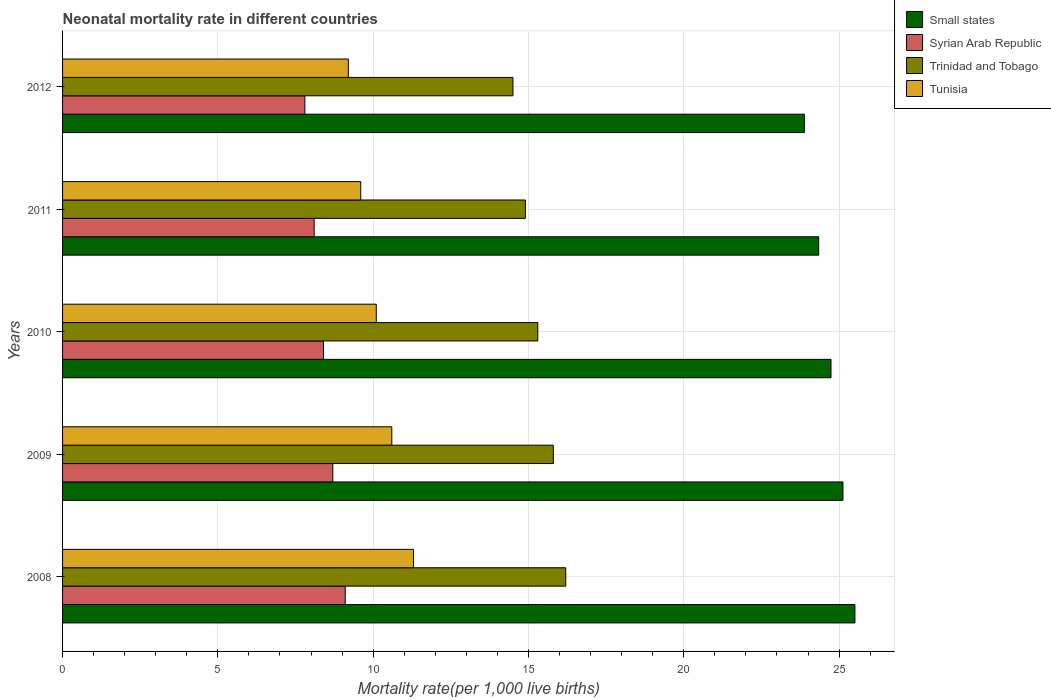How many groups of bars are there?
Ensure brevity in your answer.  5. What is the label of the 4th group of bars from the top?
Make the answer very short. 2009. What is the neonatal mortality rate in Small states in 2011?
Offer a terse response. 24.34. Across all years, what is the maximum neonatal mortality rate in Small states?
Your answer should be compact. 25.51. Across all years, what is the minimum neonatal mortality rate in Small states?
Provide a short and direct response. 23.88. In which year was the neonatal mortality rate in Tunisia minimum?
Give a very brief answer. 2012. What is the total neonatal mortality rate in Trinidad and Tobago in the graph?
Offer a terse response. 76.7. What is the difference between the neonatal mortality rate in Tunisia in 2008 and that in 2012?
Make the answer very short. 2.1. What is the difference between the neonatal mortality rate in Tunisia in 2010 and the neonatal mortality rate in Small states in 2011?
Your answer should be compact. -14.24. What is the average neonatal mortality rate in Syrian Arab Republic per year?
Offer a very short reply. 8.42. In the year 2012, what is the difference between the neonatal mortality rate in Tunisia and neonatal mortality rate in Syrian Arab Republic?
Make the answer very short. 1.4. In how many years, is the neonatal mortality rate in Tunisia greater than 12 ?
Your response must be concise. 0. What is the ratio of the neonatal mortality rate in Trinidad and Tobago in 2009 to that in 2010?
Offer a very short reply. 1.03. What is the difference between the highest and the second highest neonatal mortality rate in Small states?
Provide a succinct answer. 0.39. What is the difference between the highest and the lowest neonatal mortality rate in Tunisia?
Your answer should be compact. 2.1. What does the 3rd bar from the top in 2012 represents?
Provide a short and direct response. Syrian Arab Republic. What does the 3rd bar from the bottom in 2012 represents?
Your response must be concise. Trinidad and Tobago. Is it the case that in every year, the sum of the neonatal mortality rate in Trinidad and Tobago and neonatal mortality rate in Syrian Arab Republic is greater than the neonatal mortality rate in Small states?
Keep it short and to the point. No. How many bars are there?
Your response must be concise. 20. Are all the bars in the graph horizontal?
Offer a terse response. Yes. What is the difference between two consecutive major ticks on the X-axis?
Ensure brevity in your answer.  5. Are the values on the major ticks of X-axis written in scientific E-notation?
Your answer should be very brief. No. Where does the legend appear in the graph?
Offer a terse response. Top right. How many legend labels are there?
Your answer should be compact. 4. How are the legend labels stacked?
Make the answer very short. Vertical. What is the title of the graph?
Keep it short and to the point. Neonatal mortality rate in different countries. Does "Oman" appear as one of the legend labels in the graph?
Your answer should be compact. No. What is the label or title of the X-axis?
Provide a succinct answer. Mortality rate(per 1,0 live births). What is the Mortality rate(per 1,000 live births) of Small states in 2008?
Keep it short and to the point. 25.51. What is the Mortality rate(per 1,000 live births) of Syrian Arab Republic in 2008?
Ensure brevity in your answer.  9.1. What is the Mortality rate(per 1,000 live births) of Trinidad and Tobago in 2008?
Your answer should be compact. 16.2. What is the Mortality rate(per 1,000 live births) in Tunisia in 2008?
Offer a terse response. 11.3. What is the Mortality rate(per 1,000 live births) in Small states in 2009?
Give a very brief answer. 25.12. What is the Mortality rate(per 1,000 live births) in Syrian Arab Republic in 2009?
Keep it short and to the point. 8.7. What is the Mortality rate(per 1,000 live births) in Trinidad and Tobago in 2009?
Offer a terse response. 15.8. What is the Mortality rate(per 1,000 live births) of Tunisia in 2009?
Offer a very short reply. 10.6. What is the Mortality rate(per 1,000 live births) of Small states in 2010?
Ensure brevity in your answer.  24.74. What is the Mortality rate(per 1,000 live births) in Trinidad and Tobago in 2010?
Make the answer very short. 15.3. What is the Mortality rate(per 1,000 live births) in Small states in 2011?
Offer a terse response. 24.34. What is the Mortality rate(per 1,000 live births) of Syrian Arab Republic in 2011?
Provide a succinct answer. 8.1. What is the Mortality rate(per 1,000 live births) in Small states in 2012?
Offer a terse response. 23.88. What is the Mortality rate(per 1,000 live births) of Syrian Arab Republic in 2012?
Offer a terse response. 7.8. What is the Mortality rate(per 1,000 live births) in Trinidad and Tobago in 2012?
Provide a short and direct response. 14.5. Across all years, what is the maximum Mortality rate(per 1,000 live births) in Small states?
Make the answer very short. 25.51. Across all years, what is the maximum Mortality rate(per 1,000 live births) of Tunisia?
Offer a terse response. 11.3. Across all years, what is the minimum Mortality rate(per 1,000 live births) of Small states?
Ensure brevity in your answer.  23.88. Across all years, what is the minimum Mortality rate(per 1,000 live births) in Trinidad and Tobago?
Ensure brevity in your answer.  14.5. Across all years, what is the minimum Mortality rate(per 1,000 live births) in Tunisia?
Your answer should be very brief. 9.2. What is the total Mortality rate(per 1,000 live births) in Small states in the graph?
Provide a succinct answer. 123.6. What is the total Mortality rate(per 1,000 live births) of Syrian Arab Republic in the graph?
Offer a very short reply. 42.1. What is the total Mortality rate(per 1,000 live births) in Trinidad and Tobago in the graph?
Make the answer very short. 76.7. What is the total Mortality rate(per 1,000 live births) of Tunisia in the graph?
Ensure brevity in your answer.  50.8. What is the difference between the Mortality rate(per 1,000 live births) of Small states in 2008 and that in 2009?
Provide a short and direct response. 0.39. What is the difference between the Mortality rate(per 1,000 live births) of Tunisia in 2008 and that in 2009?
Give a very brief answer. 0.7. What is the difference between the Mortality rate(per 1,000 live births) in Small states in 2008 and that in 2010?
Your answer should be very brief. 0.77. What is the difference between the Mortality rate(per 1,000 live births) in Syrian Arab Republic in 2008 and that in 2010?
Offer a terse response. 0.7. What is the difference between the Mortality rate(per 1,000 live births) in Small states in 2008 and that in 2011?
Offer a terse response. 1.17. What is the difference between the Mortality rate(per 1,000 live births) of Syrian Arab Republic in 2008 and that in 2011?
Your answer should be very brief. 1. What is the difference between the Mortality rate(per 1,000 live births) in Trinidad and Tobago in 2008 and that in 2011?
Make the answer very short. 1.3. What is the difference between the Mortality rate(per 1,000 live births) of Tunisia in 2008 and that in 2011?
Make the answer very short. 1.7. What is the difference between the Mortality rate(per 1,000 live births) of Small states in 2008 and that in 2012?
Offer a terse response. 1.63. What is the difference between the Mortality rate(per 1,000 live births) of Small states in 2009 and that in 2010?
Make the answer very short. 0.38. What is the difference between the Mortality rate(per 1,000 live births) in Syrian Arab Republic in 2009 and that in 2010?
Provide a short and direct response. 0.3. What is the difference between the Mortality rate(per 1,000 live births) in Tunisia in 2009 and that in 2010?
Provide a short and direct response. 0.5. What is the difference between the Mortality rate(per 1,000 live births) in Small states in 2009 and that in 2011?
Provide a succinct answer. 0.78. What is the difference between the Mortality rate(per 1,000 live births) in Syrian Arab Republic in 2009 and that in 2011?
Offer a very short reply. 0.6. What is the difference between the Mortality rate(per 1,000 live births) of Small states in 2009 and that in 2012?
Provide a succinct answer. 1.24. What is the difference between the Mortality rate(per 1,000 live births) of Syrian Arab Republic in 2009 and that in 2012?
Make the answer very short. 0.9. What is the difference between the Mortality rate(per 1,000 live births) in Small states in 2010 and that in 2011?
Your response must be concise. 0.4. What is the difference between the Mortality rate(per 1,000 live births) in Small states in 2010 and that in 2012?
Give a very brief answer. 0.86. What is the difference between the Mortality rate(per 1,000 live births) in Syrian Arab Republic in 2010 and that in 2012?
Your answer should be very brief. 0.6. What is the difference between the Mortality rate(per 1,000 live births) in Trinidad and Tobago in 2010 and that in 2012?
Your response must be concise. 0.8. What is the difference between the Mortality rate(per 1,000 live births) in Tunisia in 2010 and that in 2012?
Your response must be concise. 0.9. What is the difference between the Mortality rate(per 1,000 live births) in Small states in 2011 and that in 2012?
Keep it short and to the point. 0.46. What is the difference between the Mortality rate(per 1,000 live births) of Syrian Arab Republic in 2011 and that in 2012?
Offer a very short reply. 0.3. What is the difference between the Mortality rate(per 1,000 live births) in Small states in 2008 and the Mortality rate(per 1,000 live births) in Syrian Arab Republic in 2009?
Make the answer very short. 16.81. What is the difference between the Mortality rate(per 1,000 live births) of Small states in 2008 and the Mortality rate(per 1,000 live births) of Trinidad and Tobago in 2009?
Offer a very short reply. 9.71. What is the difference between the Mortality rate(per 1,000 live births) in Small states in 2008 and the Mortality rate(per 1,000 live births) in Tunisia in 2009?
Offer a very short reply. 14.91. What is the difference between the Mortality rate(per 1,000 live births) of Trinidad and Tobago in 2008 and the Mortality rate(per 1,000 live births) of Tunisia in 2009?
Ensure brevity in your answer.  5.6. What is the difference between the Mortality rate(per 1,000 live births) in Small states in 2008 and the Mortality rate(per 1,000 live births) in Syrian Arab Republic in 2010?
Ensure brevity in your answer.  17.11. What is the difference between the Mortality rate(per 1,000 live births) of Small states in 2008 and the Mortality rate(per 1,000 live births) of Trinidad and Tobago in 2010?
Offer a terse response. 10.21. What is the difference between the Mortality rate(per 1,000 live births) in Small states in 2008 and the Mortality rate(per 1,000 live births) in Tunisia in 2010?
Provide a succinct answer. 15.41. What is the difference between the Mortality rate(per 1,000 live births) of Trinidad and Tobago in 2008 and the Mortality rate(per 1,000 live births) of Tunisia in 2010?
Provide a succinct answer. 6.1. What is the difference between the Mortality rate(per 1,000 live births) of Small states in 2008 and the Mortality rate(per 1,000 live births) of Syrian Arab Republic in 2011?
Your answer should be compact. 17.41. What is the difference between the Mortality rate(per 1,000 live births) of Small states in 2008 and the Mortality rate(per 1,000 live births) of Trinidad and Tobago in 2011?
Ensure brevity in your answer.  10.61. What is the difference between the Mortality rate(per 1,000 live births) of Small states in 2008 and the Mortality rate(per 1,000 live births) of Tunisia in 2011?
Ensure brevity in your answer.  15.91. What is the difference between the Mortality rate(per 1,000 live births) in Syrian Arab Republic in 2008 and the Mortality rate(per 1,000 live births) in Tunisia in 2011?
Offer a very short reply. -0.5. What is the difference between the Mortality rate(per 1,000 live births) in Trinidad and Tobago in 2008 and the Mortality rate(per 1,000 live births) in Tunisia in 2011?
Your answer should be compact. 6.6. What is the difference between the Mortality rate(per 1,000 live births) in Small states in 2008 and the Mortality rate(per 1,000 live births) in Syrian Arab Republic in 2012?
Offer a very short reply. 17.71. What is the difference between the Mortality rate(per 1,000 live births) of Small states in 2008 and the Mortality rate(per 1,000 live births) of Trinidad and Tobago in 2012?
Your answer should be compact. 11.01. What is the difference between the Mortality rate(per 1,000 live births) of Small states in 2008 and the Mortality rate(per 1,000 live births) of Tunisia in 2012?
Provide a short and direct response. 16.31. What is the difference between the Mortality rate(per 1,000 live births) of Trinidad and Tobago in 2008 and the Mortality rate(per 1,000 live births) of Tunisia in 2012?
Your response must be concise. 7. What is the difference between the Mortality rate(per 1,000 live births) in Small states in 2009 and the Mortality rate(per 1,000 live births) in Syrian Arab Republic in 2010?
Make the answer very short. 16.72. What is the difference between the Mortality rate(per 1,000 live births) of Small states in 2009 and the Mortality rate(per 1,000 live births) of Trinidad and Tobago in 2010?
Ensure brevity in your answer.  9.82. What is the difference between the Mortality rate(per 1,000 live births) of Small states in 2009 and the Mortality rate(per 1,000 live births) of Tunisia in 2010?
Your answer should be very brief. 15.02. What is the difference between the Mortality rate(per 1,000 live births) of Syrian Arab Republic in 2009 and the Mortality rate(per 1,000 live births) of Trinidad and Tobago in 2010?
Your answer should be very brief. -6.6. What is the difference between the Mortality rate(per 1,000 live births) of Syrian Arab Republic in 2009 and the Mortality rate(per 1,000 live births) of Tunisia in 2010?
Give a very brief answer. -1.4. What is the difference between the Mortality rate(per 1,000 live births) of Trinidad and Tobago in 2009 and the Mortality rate(per 1,000 live births) of Tunisia in 2010?
Ensure brevity in your answer.  5.7. What is the difference between the Mortality rate(per 1,000 live births) of Small states in 2009 and the Mortality rate(per 1,000 live births) of Syrian Arab Republic in 2011?
Provide a short and direct response. 17.02. What is the difference between the Mortality rate(per 1,000 live births) of Small states in 2009 and the Mortality rate(per 1,000 live births) of Trinidad and Tobago in 2011?
Offer a very short reply. 10.22. What is the difference between the Mortality rate(per 1,000 live births) in Small states in 2009 and the Mortality rate(per 1,000 live births) in Tunisia in 2011?
Provide a short and direct response. 15.52. What is the difference between the Mortality rate(per 1,000 live births) of Small states in 2009 and the Mortality rate(per 1,000 live births) of Syrian Arab Republic in 2012?
Your answer should be compact. 17.32. What is the difference between the Mortality rate(per 1,000 live births) of Small states in 2009 and the Mortality rate(per 1,000 live births) of Trinidad and Tobago in 2012?
Offer a very short reply. 10.62. What is the difference between the Mortality rate(per 1,000 live births) of Small states in 2009 and the Mortality rate(per 1,000 live births) of Tunisia in 2012?
Ensure brevity in your answer.  15.92. What is the difference between the Mortality rate(per 1,000 live births) of Syrian Arab Republic in 2009 and the Mortality rate(per 1,000 live births) of Trinidad and Tobago in 2012?
Ensure brevity in your answer.  -5.8. What is the difference between the Mortality rate(per 1,000 live births) of Syrian Arab Republic in 2009 and the Mortality rate(per 1,000 live births) of Tunisia in 2012?
Your response must be concise. -0.5. What is the difference between the Mortality rate(per 1,000 live births) of Trinidad and Tobago in 2009 and the Mortality rate(per 1,000 live births) of Tunisia in 2012?
Give a very brief answer. 6.6. What is the difference between the Mortality rate(per 1,000 live births) in Small states in 2010 and the Mortality rate(per 1,000 live births) in Syrian Arab Republic in 2011?
Keep it short and to the point. 16.64. What is the difference between the Mortality rate(per 1,000 live births) of Small states in 2010 and the Mortality rate(per 1,000 live births) of Trinidad and Tobago in 2011?
Provide a short and direct response. 9.84. What is the difference between the Mortality rate(per 1,000 live births) in Small states in 2010 and the Mortality rate(per 1,000 live births) in Tunisia in 2011?
Offer a very short reply. 15.14. What is the difference between the Mortality rate(per 1,000 live births) of Syrian Arab Republic in 2010 and the Mortality rate(per 1,000 live births) of Tunisia in 2011?
Keep it short and to the point. -1.2. What is the difference between the Mortality rate(per 1,000 live births) in Trinidad and Tobago in 2010 and the Mortality rate(per 1,000 live births) in Tunisia in 2011?
Offer a very short reply. 5.7. What is the difference between the Mortality rate(per 1,000 live births) in Small states in 2010 and the Mortality rate(per 1,000 live births) in Syrian Arab Republic in 2012?
Give a very brief answer. 16.94. What is the difference between the Mortality rate(per 1,000 live births) in Small states in 2010 and the Mortality rate(per 1,000 live births) in Trinidad and Tobago in 2012?
Offer a terse response. 10.24. What is the difference between the Mortality rate(per 1,000 live births) of Small states in 2010 and the Mortality rate(per 1,000 live births) of Tunisia in 2012?
Keep it short and to the point. 15.54. What is the difference between the Mortality rate(per 1,000 live births) of Syrian Arab Republic in 2010 and the Mortality rate(per 1,000 live births) of Tunisia in 2012?
Give a very brief answer. -0.8. What is the difference between the Mortality rate(per 1,000 live births) in Small states in 2011 and the Mortality rate(per 1,000 live births) in Syrian Arab Republic in 2012?
Provide a succinct answer. 16.54. What is the difference between the Mortality rate(per 1,000 live births) of Small states in 2011 and the Mortality rate(per 1,000 live births) of Trinidad and Tobago in 2012?
Ensure brevity in your answer.  9.84. What is the difference between the Mortality rate(per 1,000 live births) in Small states in 2011 and the Mortality rate(per 1,000 live births) in Tunisia in 2012?
Offer a terse response. 15.14. What is the difference between the Mortality rate(per 1,000 live births) in Syrian Arab Republic in 2011 and the Mortality rate(per 1,000 live births) in Trinidad and Tobago in 2012?
Provide a short and direct response. -6.4. What is the difference between the Mortality rate(per 1,000 live births) in Syrian Arab Republic in 2011 and the Mortality rate(per 1,000 live births) in Tunisia in 2012?
Ensure brevity in your answer.  -1.1. What is the difference between the Mortality rate(per 1,000 live births) of Trinidad and Tobago in 2011 and the Mortality rate(per 1,000 live births) of Tunisia in 2012?
Keep it short and to the point. 5.7. What is the average Mortality rate(per 1,000 live births) in Small states per year?
Your answer should be compact. 24.72. What is the average Mortality rate(per 1,000 live births) of Syrian Arab Republic per year?
Offer a very short reply. 8.42. What is the average Mortality rate(per 1,000 live births) in Trinidad and Tobago per year?
Offer a very short reply. 15.34. What is the average Mortality rate(per 1,000 live births) of Tunisia per year?
Your response must be concise. 10.16. In the year 2008, what is the difference between the Mortality rate(per 1,000 live births) of Small states and Mortality rate(per 1,000 live births) of Syrian Arab Republic?
Your response must be concise. 16.41. In the year 2008, what is the difference between the Mortality rate(per 1,000 live births) of Small states and Mortality rate(per 1,000 live births) of Trinidad and Tobago?
Keep it short and to the point. 9.31. In the year 2008, what is the difference between the Mortality rate(per 1,000 live births) of Small states and Mortality rate(per 1,000 live births) of Tunisia?
Provide a succinct answer. 14.21. In the year 2008, what is the difference between the Mortality rate(per 1,000 live births) of Syrian Arab Republic and Mortality rate(per 1,000 live births) of Trinidad and Tobago?
Give a very brief answer. -7.1. In the year 2008, what is the difference between the Mortality rate(per 1,000 live births) in Trinidad and Tobago and Mortality rate(per 1,000 live births) in Tunisia?
Ensure brevity in your answer.  4.9. In the year 2009, what is the difference between the Mortality rate(per 1,000 live births) of Small states and Mortality rate(per 1,000 live births) of Syrian Arab Republic?
Offer a very short reply. 16.42. In the year 2009, what is the difference between the Mortality rate(per 1,000 live births) in Small states and Mortality rate(per 1,000 live births) in Trinidad and Tobago?
Your answer should be very brief. 9.32. In the year 2009, what is the difference between the Mortality rate(per 1,000 live births) of Small states and Mortality rate(per 1,000 live births) of Tunisia?
Keep it short and to the point. 14.52. In the year 2009, what is the difference between the Mortality rate(per 1,000 live births) in Trinidad and Tobago and Mortality rate(per 1,000 live births) in Tunisia?
Provide a succinct answer. 5.2. In the year 2010, what is the difference between the Mortality rate(per 1,000 live births) in Small states and Mortality rate(per 1,000 live births) in Syrian Arab Republic?
Ensure brevity in your answer.  16.34. In the year 2010, what is the difference between the Mortality rate(per 1,000 live births) in Small states and Mortality rate(per 1,000 live births) in Trinidad and Tobago?
Offer a terse response. 9.44. In the year 2010, what is the difference between the Mortality rate(per 1,000 live births) of Small states and Mortality rate(per 1,000 live births) of Tunisia?
Keep it short and to the point. 14.64. In the year 2010, what is the difference between the Mortality rate(per 1,000 live births) in Syrian Arab Republic and Mortality rate(per 1,000 live births) in Trinidad and Tobago?
Provide a short and direct response. -6.9. In the year 2010, what is the difference between the Mortality rate(per 1,000 live births) in Trinidad and Tobago and Mortality rate(per 1,000 live births) in Tunisia?
Your response must be concise. 5.2. In the year 2011, what is the difference between the Mortality rate(per 1,000 live births) in Small states and Mortality rate(per 1,000 live births) in Syrian Arab Republic?
Ensure brevity in your answer.  16.24. In the year 2011, what is the difference between the Mortality rate(per 1,000 live births) in Small states and Mortality rate(per 1,000 live births) in Trinidad and Tobago?
Your answer should be compact. 9.44. In the year 2011, what is the difference between the Mortality rate(per 1,000 live births) in Small states and Mortality rate(per 1,000 live births) in Tunisia?
Offer a very short reply. 14.74. In the year 2011, what is the difference between the Mortality rate(per 1,000 live births) in Syrian Arab Republic and Mortality rate(per 1,000 live births) in Trinidad and Tobago?
Your answer should be compact. -6.8. In the year 2011, what is the difference between the Mortality rate(per 1,000 live births) in Trinidad and Tobago and Mortality rate(per 1,000 live births) in Tunisia?
Provide a short and direct response. 5.3. In the year 2012, what is the difference between the Mortality rate(per 1,000 live births) of Small states and Mortality rate(per 1,000 live births) of Syrian Arab Republic?
Ensure brevity in your answer.  16.08. In the year 2012, what is the difference between the Mortality rate(per 1,000 live births) in Small states and Mortality rate(per 1,000 live births) in Trinidad and Tobago?
Your answer should be very brief. 9.38. In the year 2012, what is the difference between the Mortality rate(per 1,000 live births) of Small states and Mortality rate(per 1,000 live births) of Tunisia?
Provide a succinct answer. 14.68. In the year 2012, what is the difference between the Mortality rate(per 1,000 live births) in Syrian Arab Republic and Mortality rate(per 1,000 live births) in Trinidad and Tobago?
Make the answer very short. -6.7. In the year 2012, what is the difference between the Mortality rate(per 1,000 live births) of Syrian Arab Republic and Mortality rate(per 1,000 live births) of Tunisia?
Make the answer very short. -1.4. What is the ratio of the Mortality rate(per 1,000 live births) of Small states in 2008 to that in 2009?
Make the answer very short. 1.02. What is the ratio of the Mortality rate(per 1,000 live births) in Syrian Arab Republic in 2008 to that in 2009?
Provide a short and direct response. 1.05. What is the ratio of the Mortality rate(per 1,000 live births) in Trinidad and Tobago in 2008 to that in 2009?
Your answer should be compact. 1.03. What is the ratio of the Mortality rate(per 1,000 live births) in Tunisia in 2008 to that in 2009?
Keep it short and to the point. 1.07. What is the ratio of the Mortality rate(per 1,000 live births) in Small states in 2008 to that in 2010?
Your answer should be very brief. 1.03. What is the ratio of the Mortality rate(per 1,000 live births) in Syrian Arab Republic in 2008 to that in 2010?
Your answer should be compact. 1.08. What is the ratio of the Mortality rate(per 1,000 live births) in Trinidad and Tobago in 2008 to that in 2010?
Provide a short and direct response. 1.06. What is the ratio of the Mortality rate(per 1,000 live births) in Tunisia in 2008 to that in 2010?
Offer a very short reply. 1.12. What is the ratio of the Mortality rate(per 1,000 live births) of Small states in 2008 to that in 2011?
Your response must be concise. 1.05. What is the ratio of the Mortality rate(per 1,000 live births) in Syrian Arab Republic in 2008 to that in 2011?
Provide a succinct answer. 1.12. What is the ratio of the Mortality rate(per 1,000 live births) of Trinidad and Tobago in 2008 to that in 2011?
Keep it short and to the point. 1.09. What is the ratio of the Mortality rate(per 1,000 live births) in Tunisia in 2008 to that in 2011?
Offer a terse response. 1.18. What is the ratio of the Mortality rate(per 1,000 live births) in Small states in 2008 to that in 2012?
Make the answer very short. 1.07. What is the ratio of the Mortality rate(per 1,000 live births) of Trinidad and Tobago in 2008 to that in 2012?
Provide a short and direct response. 1.12. What is the ratio of the Mortality rate(per 1,000 live births) of Tunisia in 2008 to that in 2012?
Your answer should be very brief. 1.23. What is the ratio of the Mortality rate(per 1,000 live births) in Small states in 2009 to that in 2010?
Your answer should be very brief. 1.02. What is the ratio of the Mortality rate(per 1,000 live births) of Syrian Arab Republic in 2009 to that in 2010?
Provide a short and direct response. 1.04. What is the ratio of the Mortality rate(per 1,000 live births) in Trinidad and Tobago in 2009 to that in 2010?
Keep it short and to the point. 1.03. What is the ratio of the Mortality rate(per 1,000 live births) of Tunisia in 2009 to that in 2010?
Your response must be concise. 1.05. What is the ratio of the Mortality rate(per 1,000 live births) of Small states in 2009 to that in 2011?
Your answer should be very brief. 1.03. What is the ratio of the Mortality rate(per 1,000 live births) in Syrian Arab Republic in 2009 to that in 2011?
Give a very brief answer. 1.07. What is the ratio of the Mortality rate(per 1,000 live births) in Trinidad and Tobago in 2009 to that in 2011?
Provide a succinct answer. 1.06. What is the ratio of the Mortality rate(per 1,000 live births) of Tunisia in 2009 to that in 2011?
Keep it short and to the point. 1.1. What is the ratio of the Mortality rate(per 1,000 live births) in Small states in 2009 to that in 2012?
Give a very brief answer. 1.05. What is the ratio of the Mortality rate(per 1,000 live births) of Syrian Arab Republic in 2009 to that in 2012?
Ensure brevity in your answer.  1.12. What is the ratio of the Mortality rate(per 1,000 live births) of Trinidad and Tobago in 2009 to that in 2012?
Keep it short and to the point. 1.09. What is the ratio of the Mortality rate(per 1,000 live births) of Tunisia in 2009 to that in 2012?
Ensure brevity in your answer.  1.15. What is the ratio of the Mortality rate(per 1,000 live births) in Small states in 2010 to that in 2011?
Give a very brief answer. 1.02. What is the ratio of the Mortality rate(per 1,000 live births) in Trinidad and Tobago in 2010 to that in 2011?
Keep it short and to the point. 1.03. What is the ratio of the Mortality rate(per 1,000 live births) in Tunisia in 2010 to that in 2011?
Your answer should be compact. 1.05. What is the ratio of the Mortality rate(per 1,000 live births) in Small states in 2010 to that in 2012?
Keep it short and to the point. 1.04. What is the ratio of the Mortality rate(per 1,000 live births) of Syrian Arab Republic in 2010 to that in 2012?
Offer a very short reply. 1.08. What is the ratio of the Mortality rate(per 1,000 live births) in Trinidad and Tobago in 2010 to that in 2012?
Make the answer very short. 1.06. What is the ratio of the Mortality rate(per 1,000 live births) in Tunisia in 2010 to that in 2012?
Keep it short and to the point. 1.1. What is the ratio of the Mortality rate(per 1,000 live births) of Small states in 2011 to that in 2012?
Ensure brevity in your answer.  1.02. What is the ratio of the Mortality rate(per 1,000 live births) in Trinidad and Tobago in 2011 to that in 2012?
Ensure brevity in your answer.  1.03. What is the ratio of the Mortality rate(per 1,000 live births) of Tunisia in 2011 to that in 2012?
Offer a terse response. 1.04. What is the difference between the highest and the second highest Mortality rate(per 1,000 live births) in Small states?
Offer a terse response. 0.39. What is the difference between the highest and the second highest Mortality rate(per 1,000 live births) of Syrian Arab Republic?
Ensure brevity in your answer.  0.4. What is the difference between the highest and the second highest Mortality rate(per 1,000 live births) in Trinidad and Tobago?
Offer a terse response. 0.4. What is the difference between the highest and the second highest Mortality rate(per 1,000 live births) of Tunisia?
Provide a succinct answer. 0.7. What is the difference between the highest and the lowest Mortality rate(per 1,000 live births) in Small states?
Ensure brevity in your answer.  1.63. What is the difference between the highest and the lowest Mortality rate(per 1,000 live births) in Trinidad and Tobago?
Your response must be concise. 1.7. What is the difference between the highest and the lowest Mortality rate(per 1,000 live births) in Tunisia?
Your response must be concise. 2.1. 